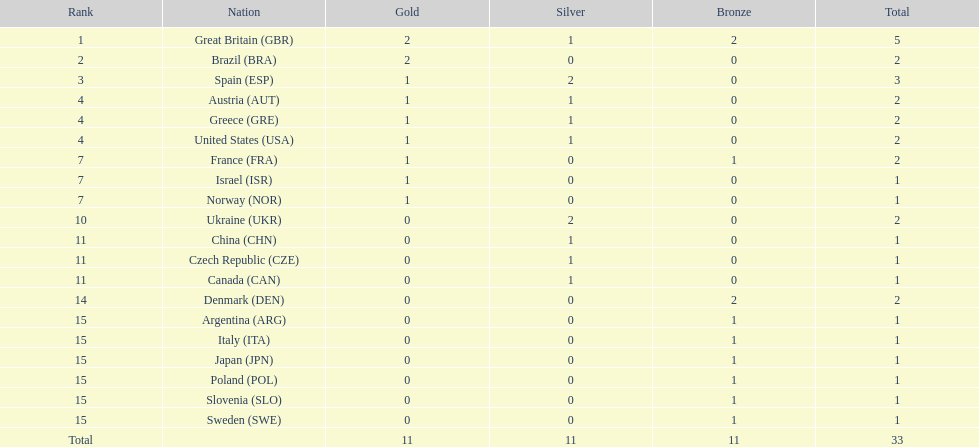Give me the full table as a dictionary. {'header': ['Rank', 'Nation', 'Gold', 'Silver', 'Bronze', 'Total'], 'rows': [['1', 'Great Britain\xa0(GBR)', '2', '1', '2', '5'], ['2', 'Brazil\xa0(BRA)', '2', '0', '0', '2'], ['3', 'Spain\xa0(ESP)', '1', '2', '0', '3'], ['4', 'Austria\xa0(AUT)', '1', '1', '0', '2'], ['4', 'Greece\xa0(GRE)', '1', '1', '0', '2'], ['4', 'United States\xa0(USA)', '1', '1', '0', '2'], ['7', 'France\xa0(FRA)', '1', '0', '1', '2'], ['7', 'Israel\xa0(ISR)', '1', '0', '0', '1'], ['7', 'Norway\xa0(NOR)', '1', '0', '0', '1'], ['10', 'Ukraine\xa0(UKR)', '0', '2', '0', '2'], ['11', 'China\xa0(CHN)', '0', '1', '0', '1'], ['11', 'Czech Republic\xa0(CZE)', '0', '1', '0', '1'], ['11', 'Canada\xa0(CAN)', '0', '1', '0', '1'], ['14', 'Denmark\xa0(DEN)', '0', '0', '2', '2'], ['15', 'Argentina\xa0(ARG)', '0', '0', '1', '1'], ['15', 'Italy\xa0(ITA)', '0', '0', '1', '1'], ['15', 'Japan\xa0(JPN)', '0', '0', '1', '1'], ['15', 'Poland\xa0(POL)', '0', '0', '1', '1'], ['15', 'Slovenia\xa0(SLO)', '0', '0', '1', '1'], ['15', 'Sweden\xa0(SWE)', '0', '0', '1', '1'], ['Total', '', '11', '11', '11', '33']]} How many countries have achieved two or more medals in sailing events? 9. 